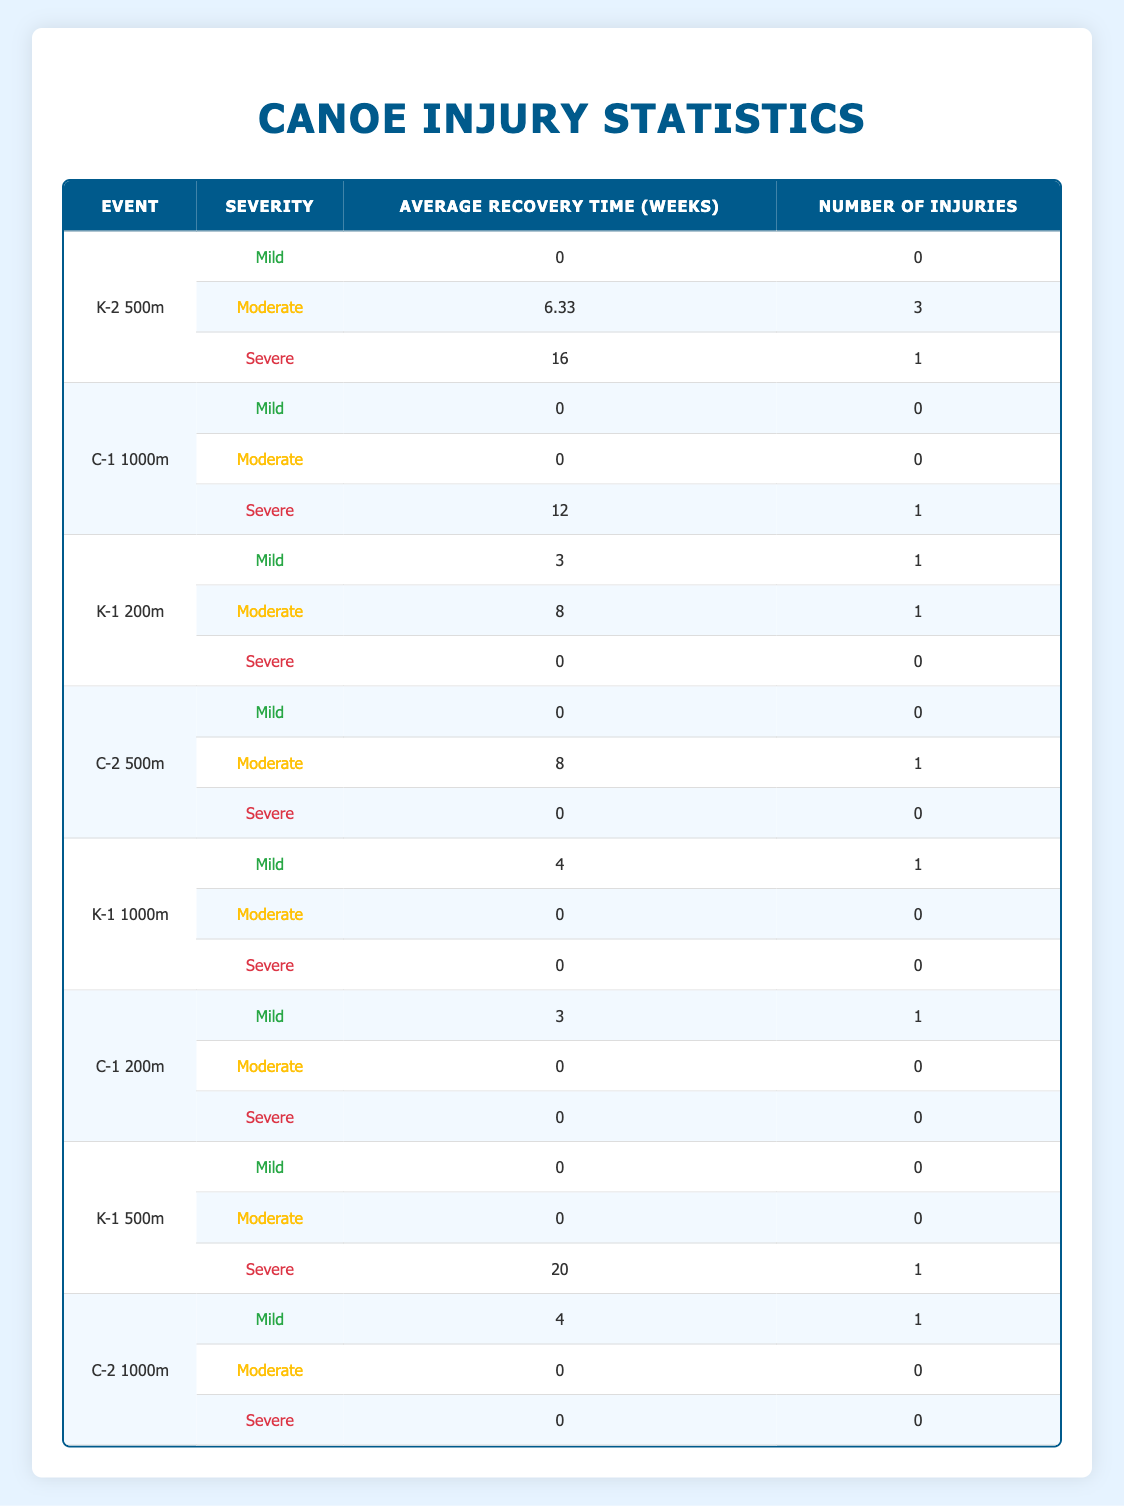What is the average recovery time for injuries in the K-2 500m event? For the K-2 500m event, the average recovery time for moderate injuries is 6.33 weeks, and for severe injuries, it is 16 weeks. There are 3 moderate injuries and 1 severe injury. To calculate the overall average recovery time, we use the formula: (6.33 * 3 + 16 * 1) / (3 + 1) = (18.99 + 16) / 4 = 34.99 / 4 = 8.75 weeks.
Answer: 8.75 weeks How many athletes experienced severe injuries in the C-1 200m event? In the C-1 200m event, there are 3 injury severity categories listed. Upon reviewing the entries, only the severe category shows a count, which is 0. Therefore, the number of athletes with severe injuries in the C-1 200m event is 0.
Answer: 0 What is the total number of injuries recorded across all events? The total number of injuries can be determined by summing the counts of injuries in each severity category across all events. Adding together these counts: (0 + 3 + 1) for K-2 500m, (0 + 0 + 1) for C-1 1000m, (1 + 1 + 0) for K-1 200m, (0 + 1 + 0) for C-2 500m, (1 + 0 + 0) for K-1 1000m, (1 + 0 + 0) for C-1 200m, (0 + 0 + 1) for K-1 500m, and (1 + 0 + 0) for C-2 1000m gives: 3 + 1 + 2 + 1 + 1 + 1 + 1 + 1 = 11.
Answer: 11 Are there any mild injuries reported for the K-1 500m event? The table explicitly shows that for the K-1 500m event, the mild injury row displays a count of injuries equal to 0. Hence, there are no mild injuries recorded for this event.
Answer: No What is the average recovery time for mild injuries across all events? To find the average recovery time for mild injuries, we look at the entries for all events classified as mild. The recovery times are: K-2 500m (0 weeks), C-1 1000m (0 weeks), K-1 200m (3 weeks), C-2 500m (0 weeks), K-1 1000m (4 weeks), C-1 200m (3 weeks), K-1 500m (0 weeks), and C-2 1000m (4 weeks). We sum these values: 0 + 0 + 3 + 0 + 4 + 3 + 0 + 4 = 14 weeks, and divide by the number of mild injuries which is 5, resulting in an average of 14 / 5 = 2.8 weeks.
Answer: 2.8 weeks 